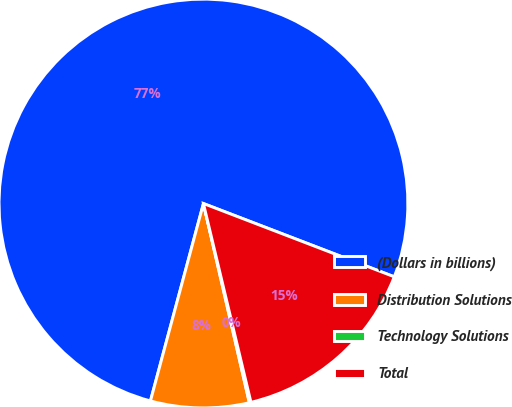Convert chart to OTSL. <chart><loc_0><loc_0><loc_500><loc_500><pie_chart><fcel>(Dollars in billions)<fcel>Distribution Solutions<fcel>Technology Solutions<fcel>Total<nl><fcel>76.66%<fcel>7.78%<fcel>0.13%<fcel>15.43%<nl></chart> 